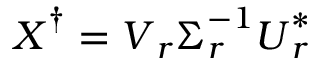Convert formula to latex. <formula><loc_0><loc_0><loc_500><loc_500>X ^ { \dag } = V _ { r } \Sigma _ { r } ^ { - 1 } U _ { r } ^ { * }</formula> 